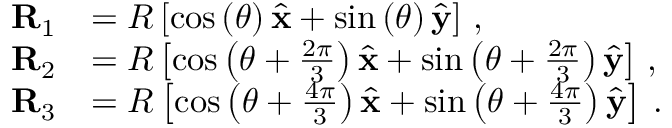Convert formula to latex. <formula><loc_0><loc_0><loc_500><loc_500>\begin{array} { r l } { R _ { 1 } } & { = R \left [ \cos \left ( \theta \right ) \hat { x } + \sin \left ( \theta \right ) \hat { y } \right ] \, , } \\ { R _ { 2 } } & { = R \left [ \cos \left ( \theta + \frac { 2 \pi } { 3 } \right ) \hat { x } + \sin \left ( \theta + \frac { 2 \pi } { 3 } \right ) \hat { y } \right ] \, , } \\ { R _ { 3 } } & { = R \left [ \cos \left ( \theta + \frac { 4 \pi } { 3 } \right ) \hat { x } + \sin \left ( \theta + \frac { 4 \pi } { 3 } \right ) \hat { y } \right ] \, . } \end{array}</formula> 